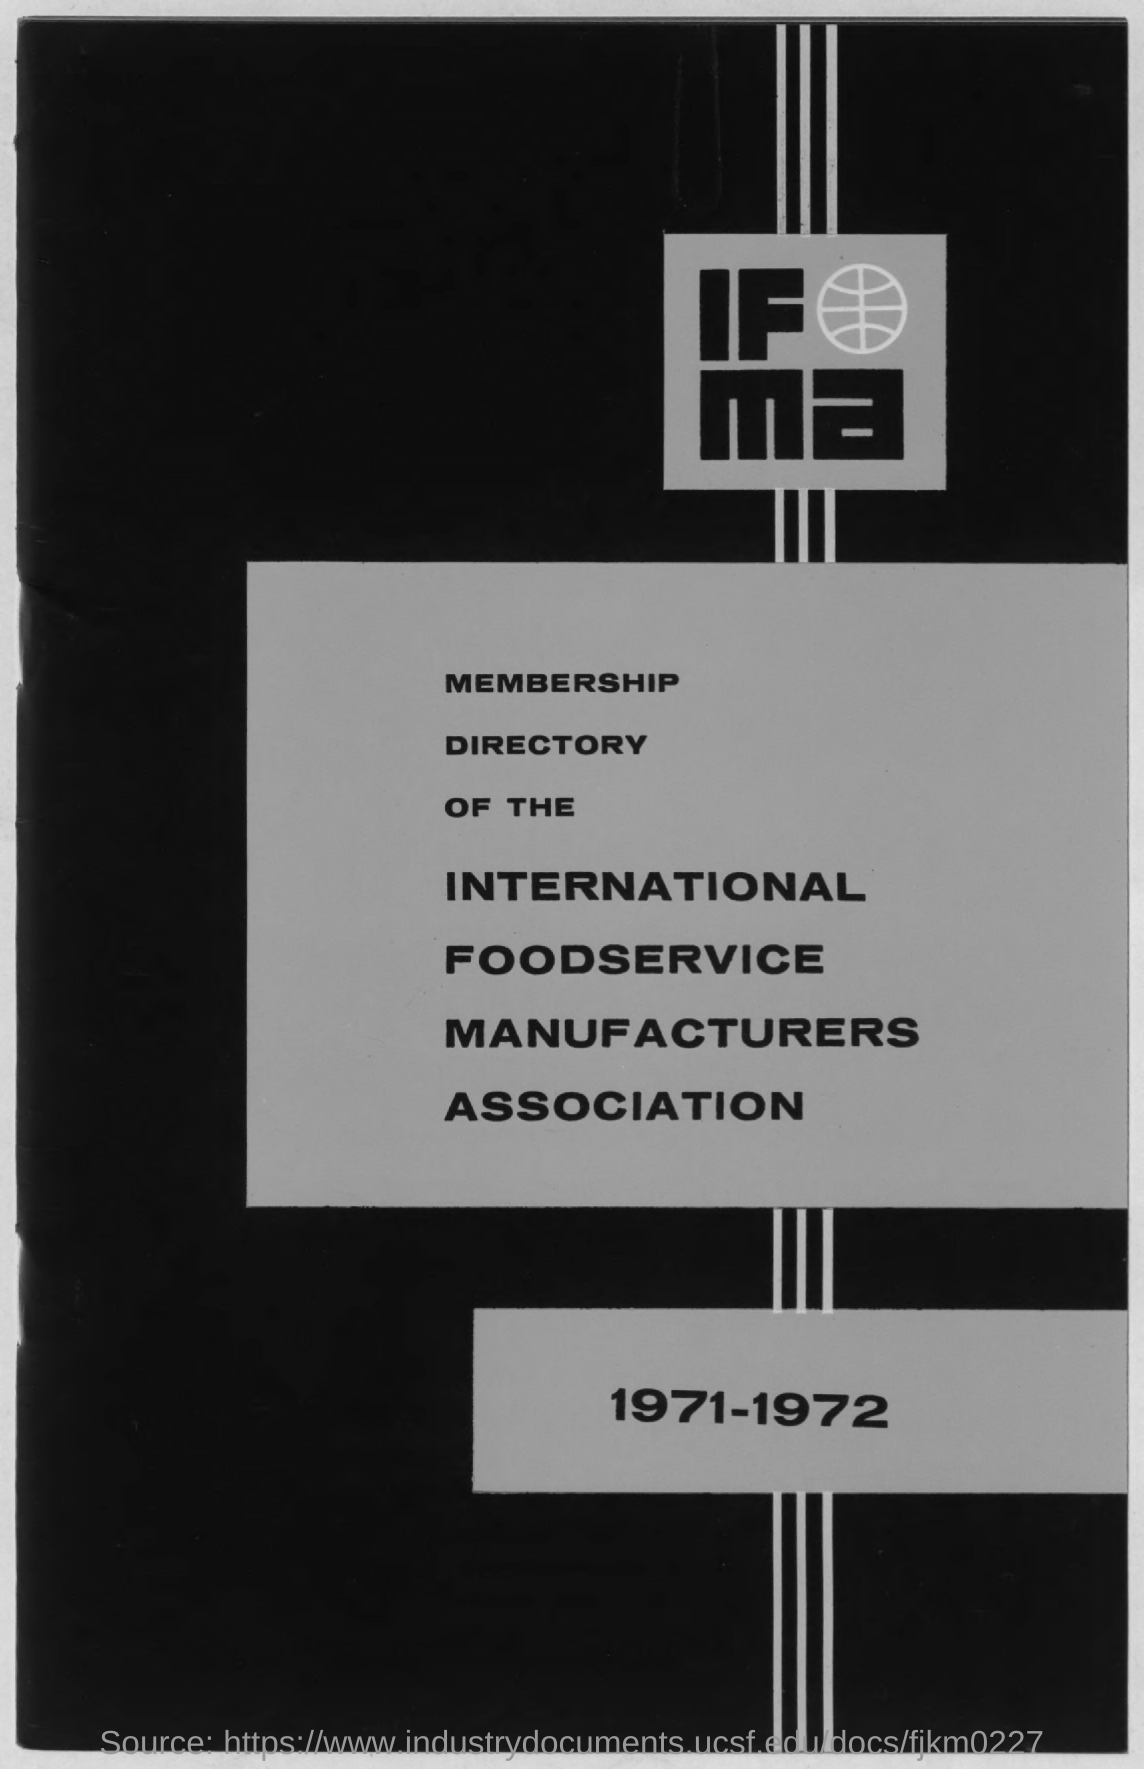Which year's directory it is?
Ensure brevity in your answer.  1971-1972. 